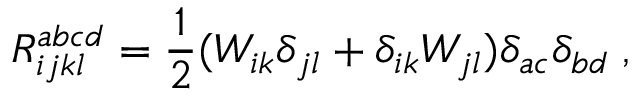Convert formula to latex. <formula><loc_0><loc_0><loc_500><loc_500>R _ { i j k l } ^ { a b c d } = \frac { 1 } { 2 } ( W _ { i k } \delta _ { j l } + \delta _ { i k } W _ { j l } ) \delta _ { a c } \delta _ { b d } \, ,</formula> 